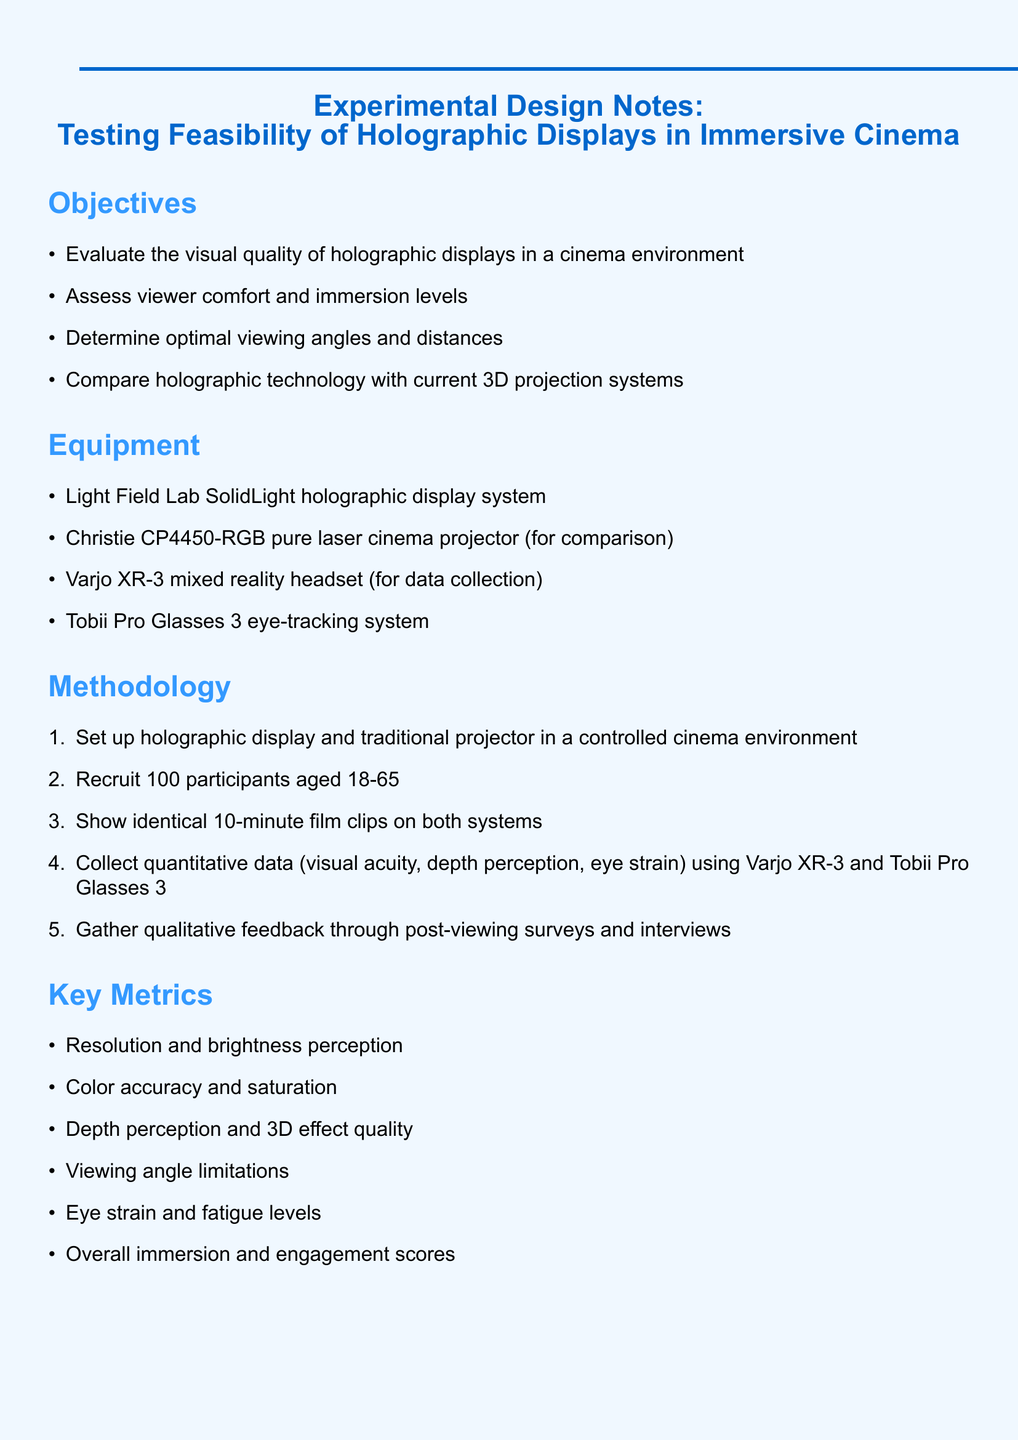What is the main objective of the experimental design? The main objective is to evaluate the visual quality of holographic displays in a cinema environment.
Answer: Evaluate the visual quality of holographic displays in a cinema environment How many participants are recruited for the study? The document states that 100 participants will be recruited for the study.
Answer: 100 participants What equipment is used for data collection? The document lists the Varjo XR-3 mixed reality headset as the equipment used for data collection.
Answer: Varjo XR-3 mixed reality headset What are the key metrics used in this experiment? The document outlines several metrics, including resolution and brightness perception.
Answer: Resolution and brightness perception What is a potential challenge mentioned in the document? The document highlights ambient light interference as a potential challenge for holographic projection.
Answer: Ambient light interference What type of data is collected after viewing the film clips? The document mentions that qualitative feedback is gathered through post-viewing surveys and interviews.
Answer: Qualitative feedback How long are the film clips shown to participants? The document specifies that 10-minute film clips are shown on both systems.
Answer: 10-minute What technology is used for eye-tracking in the study? The document states that the Tobii Pro Glasses 3 eye-tracking system is used for this purpose.
Answer: Tobii Pro Glasses 3 Which technology is compared to holographic displays? The document specifies that the Christie CP4450-RGB pure laser cinema projector is used for comparison.
Answer: Christie CP4450-RGB pure laser cinema projector 